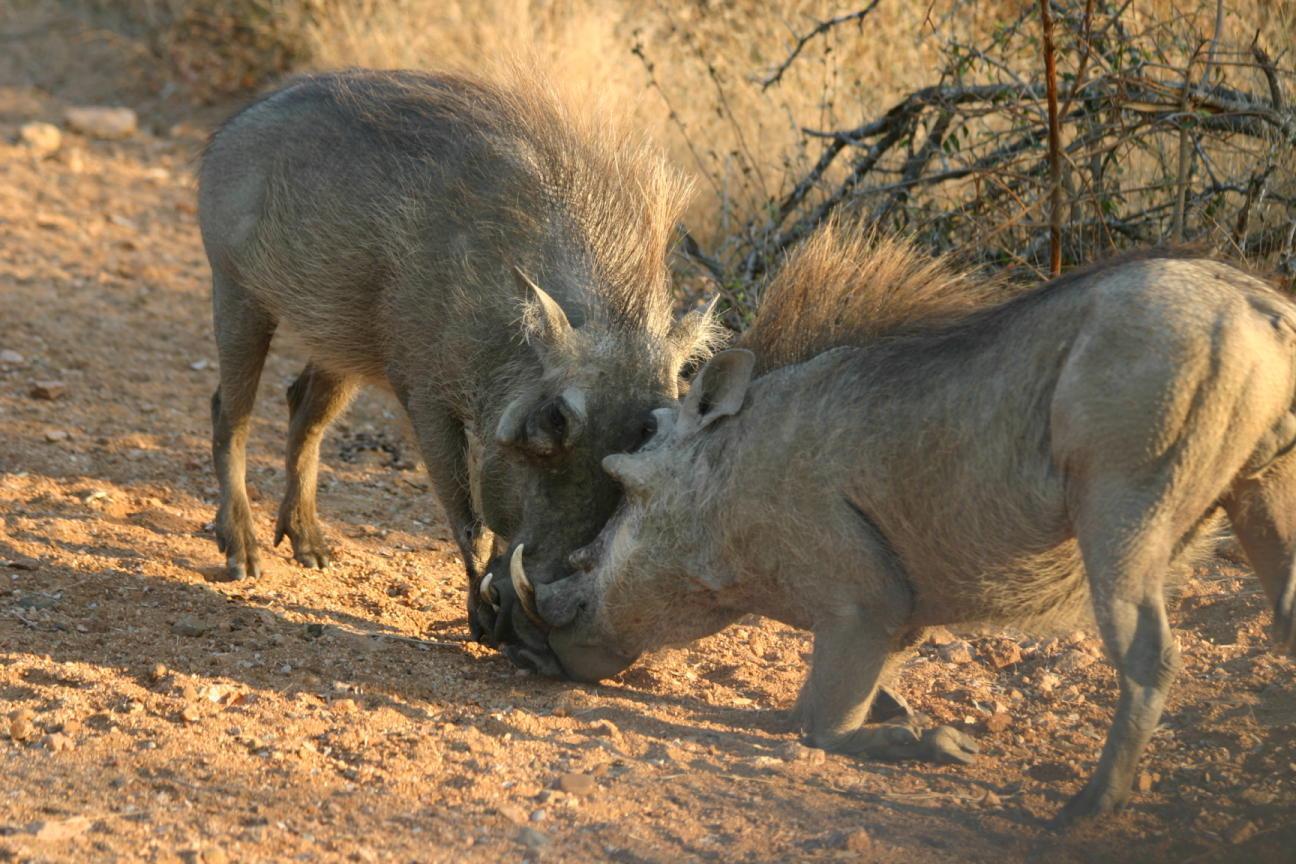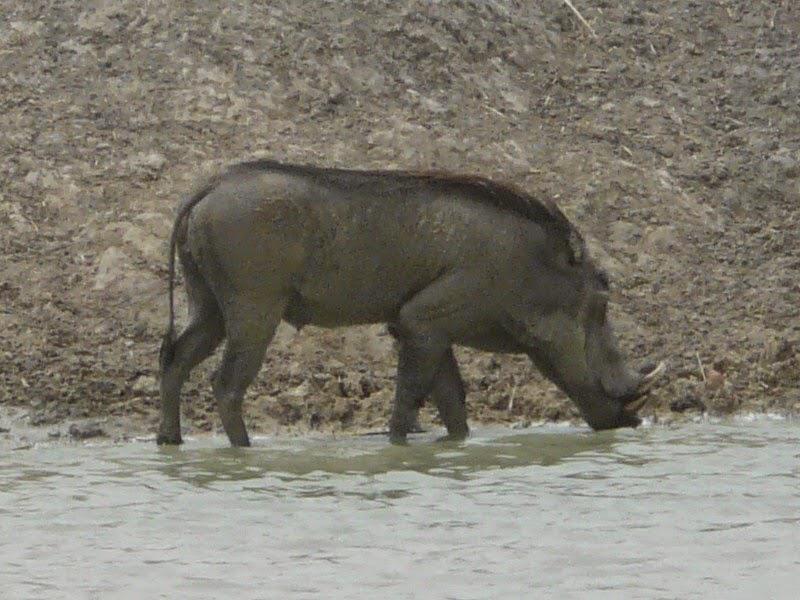The first image is the image on the left, the second image is the image on the right. Assess this claim about the two images: "There are two animals in the image on the left.". Correct or not? Answer yes or no. Yes. 